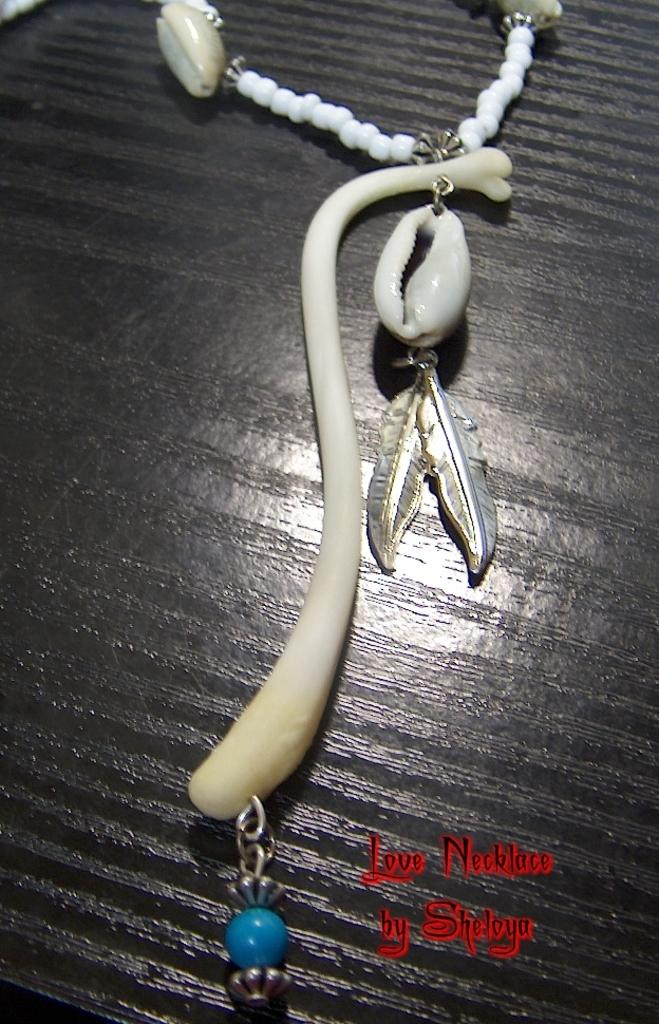What type of accessory is featured in the image? There is a necklace in the image. What decorative elements are present on the necklace? There are two shells on the necklace. On what surface is the necklace placed? The necklace is placed on a brown surface. What type of lettuce is used as a decorative element on the necklace? There is no lettuce present on the necklace; it features two shells as decorative elements. 